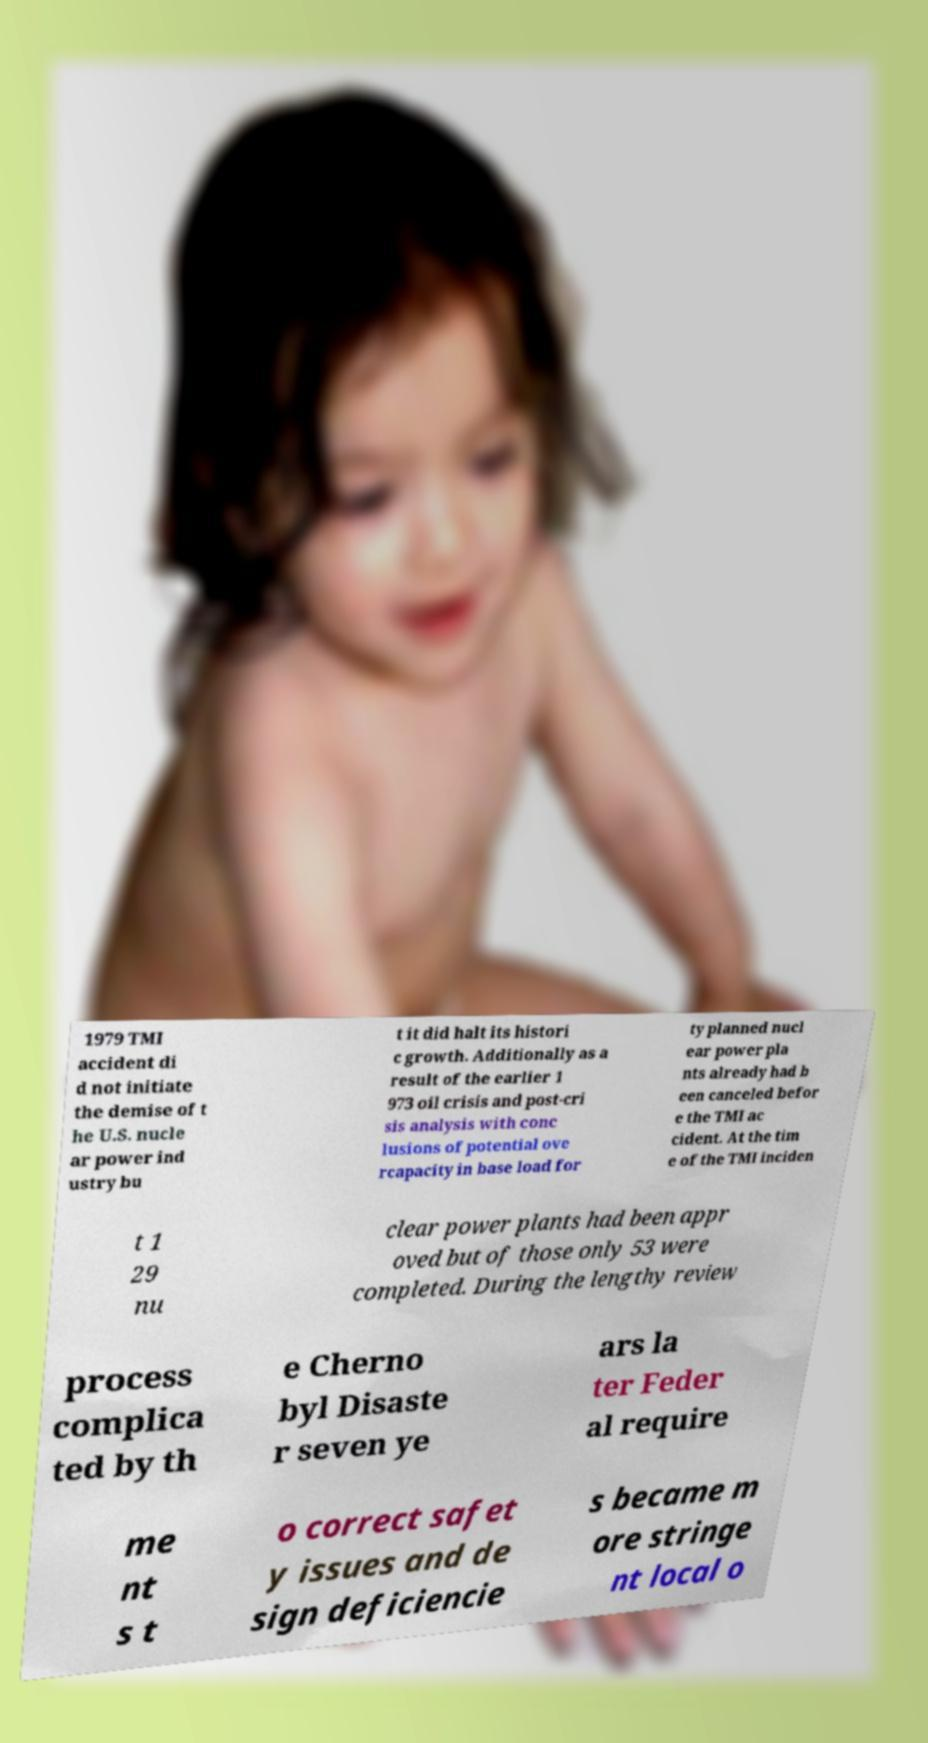Could you assist in decoding the text presented in this image and type it out clearly? 1979 TMI accident di d not initiate the demise of t he U.S. nucle ar power ind ustry bu t it did halt its histori c growth. Additionally as a result of the earlier 1 973 oil crisis and post-cri sis analysis with conc lusions of potential ove rcapacity in base load for ty planned nucl ear power pla nts already had b een canceled befor e the TMI ac cident. At the tim e of the TMI inciden t 1 29 nu clear power plants had been appr oved but of those only 53 were completed. During the lengthy review process complica ted by th e Cherno byl Disaste r seven ye ars la ter Feder al require me nt s t o correct safet y issues and de sign deficiencie s became m ore stringe nt local o 